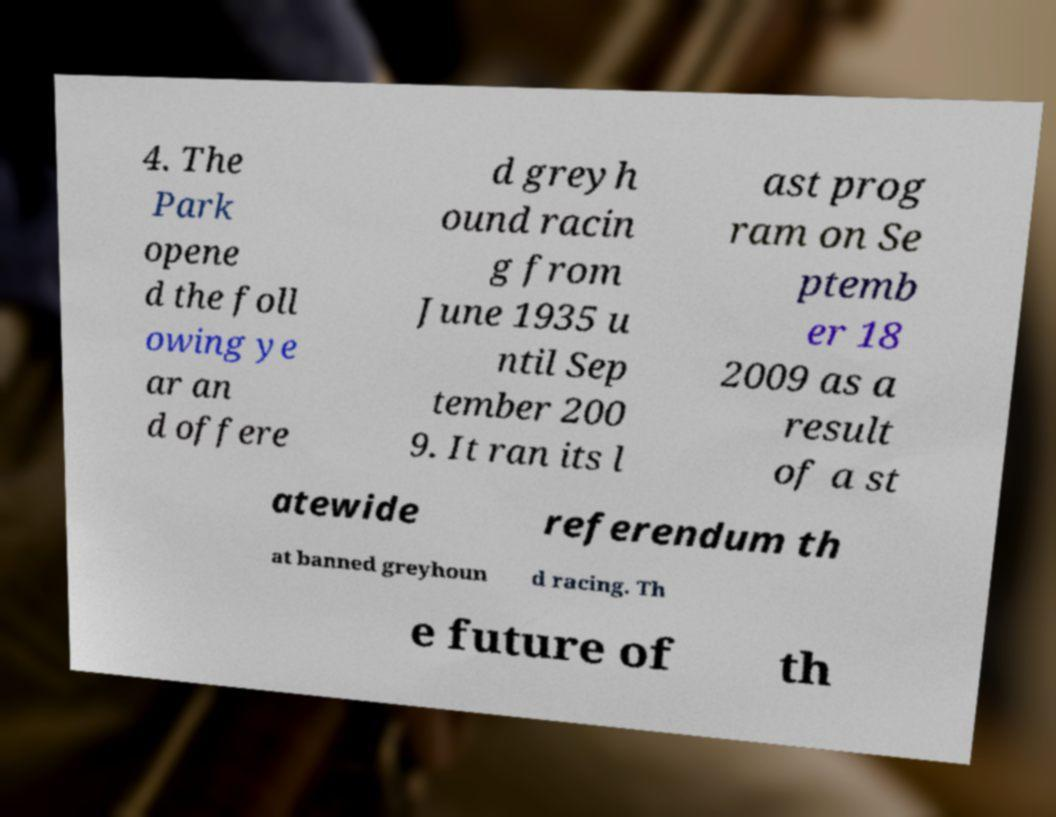Can you read and provide the text displayed in the image?This photo seems to have some interesting text. Can you extract and type it out for me? 4. The Park opene d the foll owing ye ar an d offere d greyh ound racin g from June 1935 u ntil Sep tember 200 9. It ran its l ast prog ram on Se ptemb er 18 2009 as a result of a st atewide referendum th at banned greyhoun d racing. Th e future of th 